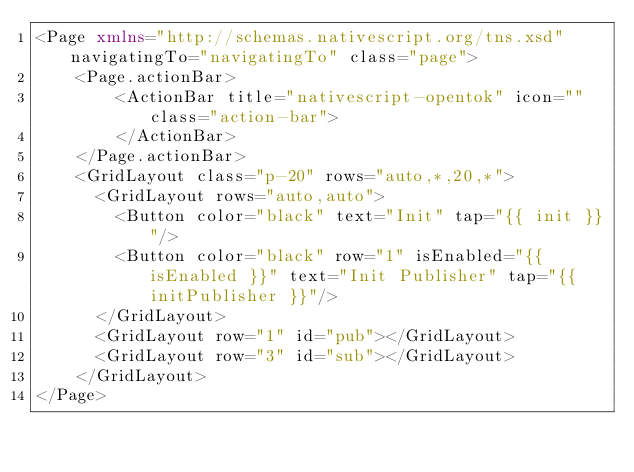Convert code to text. <code><loc_0><loc_0><loc_500><loc_500><_XML_><Page xmlns="http://schemas.nativescript.org/tns.xsd" navigatingTo="navigatingTo" class="page">
    <Page.actionBar>
        <ActionBar title="nativescript-opentok" icon="" class="action-bar">
        </ActionBar>
    </Page.actionBar>
    <GridLayout class="p-20" rows="auto,*,20,*">
      <GridLayout rows="auto,auto">
        <Button color="black" text="Init" tap="{{ init }}"/>
        <Button color="black" row="1" isEnabled="{{ isEnabled }}" text="Init Publisher" tap="{{ initPublisher }}"/>
      </GridLayout>
      <GridLayout row="1" id="pub"></GridLayout>
      <GridLayout row="3" id="sub"></GridLayout>
    </GridLayout>
</Page></code> 